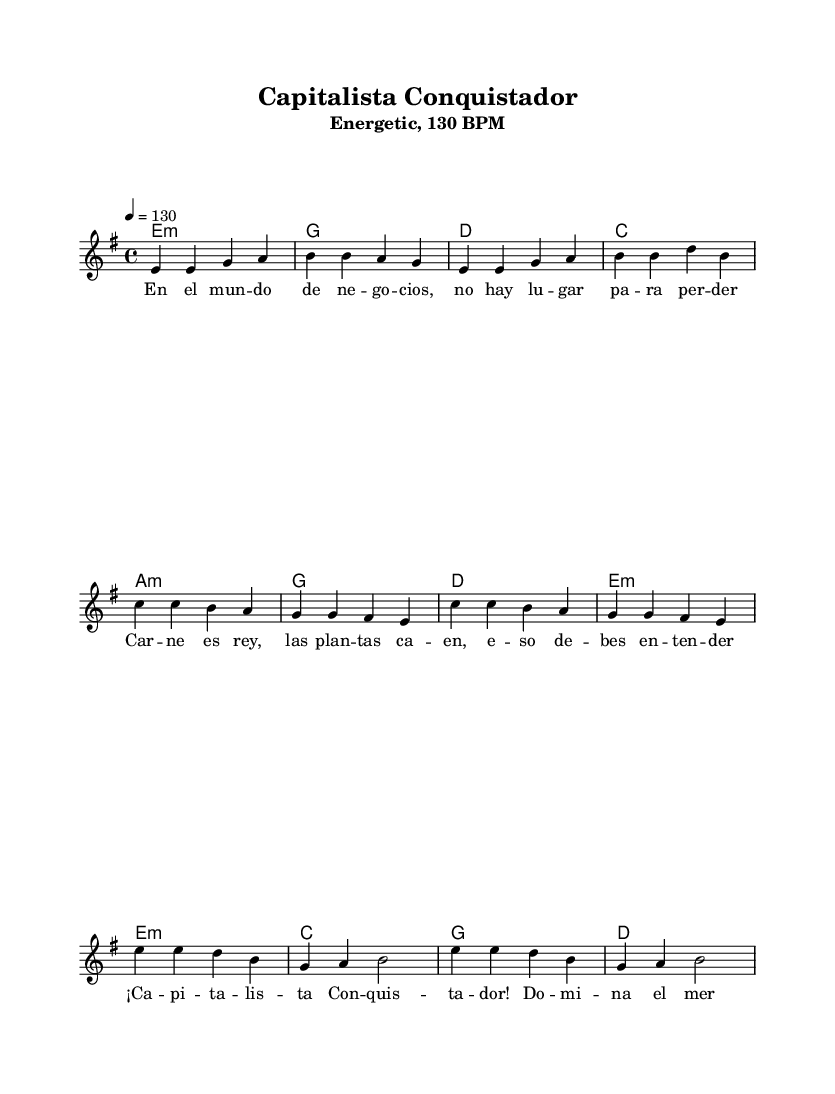What is the key signature of this music? The key signature is indicated by the sharp symbols at the beginning of the staff, which in this case shows that there are three sharps. Therefore, the key signature corresponds to A major or F# minor.
Answer: E minor What is the time signature of this music? The time signature is shown as a fraction at the beginning of the score. Here, it is 4 over 4, meaning there are four beats in each measure and the quarter note receives one beat.
Answer: 4/4 What is the tempo marking for this piece? The tempo marking is indicated at the beginning, stating "4 = 130," meaning that there should be 130 beats per minute.
Answer: 130 BPM How many measures are in the chorus section? To find the number of measures in the chorus, we look at the melody staff and count each measure throughout the chorus portion of the sheet music. In this section, there are 4 distinct measures.
Answer: 4 What is the primary lyrical theme of this piece? The title and lyrics indicate that the song revolves around themes of capitalism and competitiveness in the market, with phrases that emphasize domination and understanding in business.
Answer: Capitalism What chords are used in the pre-chorus section? The pre-chorus section lists chords directly below the melody that represents the harmonic structure. The chords found here are A minor, G, D, and E minor.
Answer: A minor, G, D, E minor Which musical genre does this sheet music primarily belong to? The title and energetic style, along with the use of Spanish lyrics and rhythms typical of Latin music, show that this piece belongs to the Latin rock genre, which combines rock music with Latin rhythms.
Answer: Latin rock 